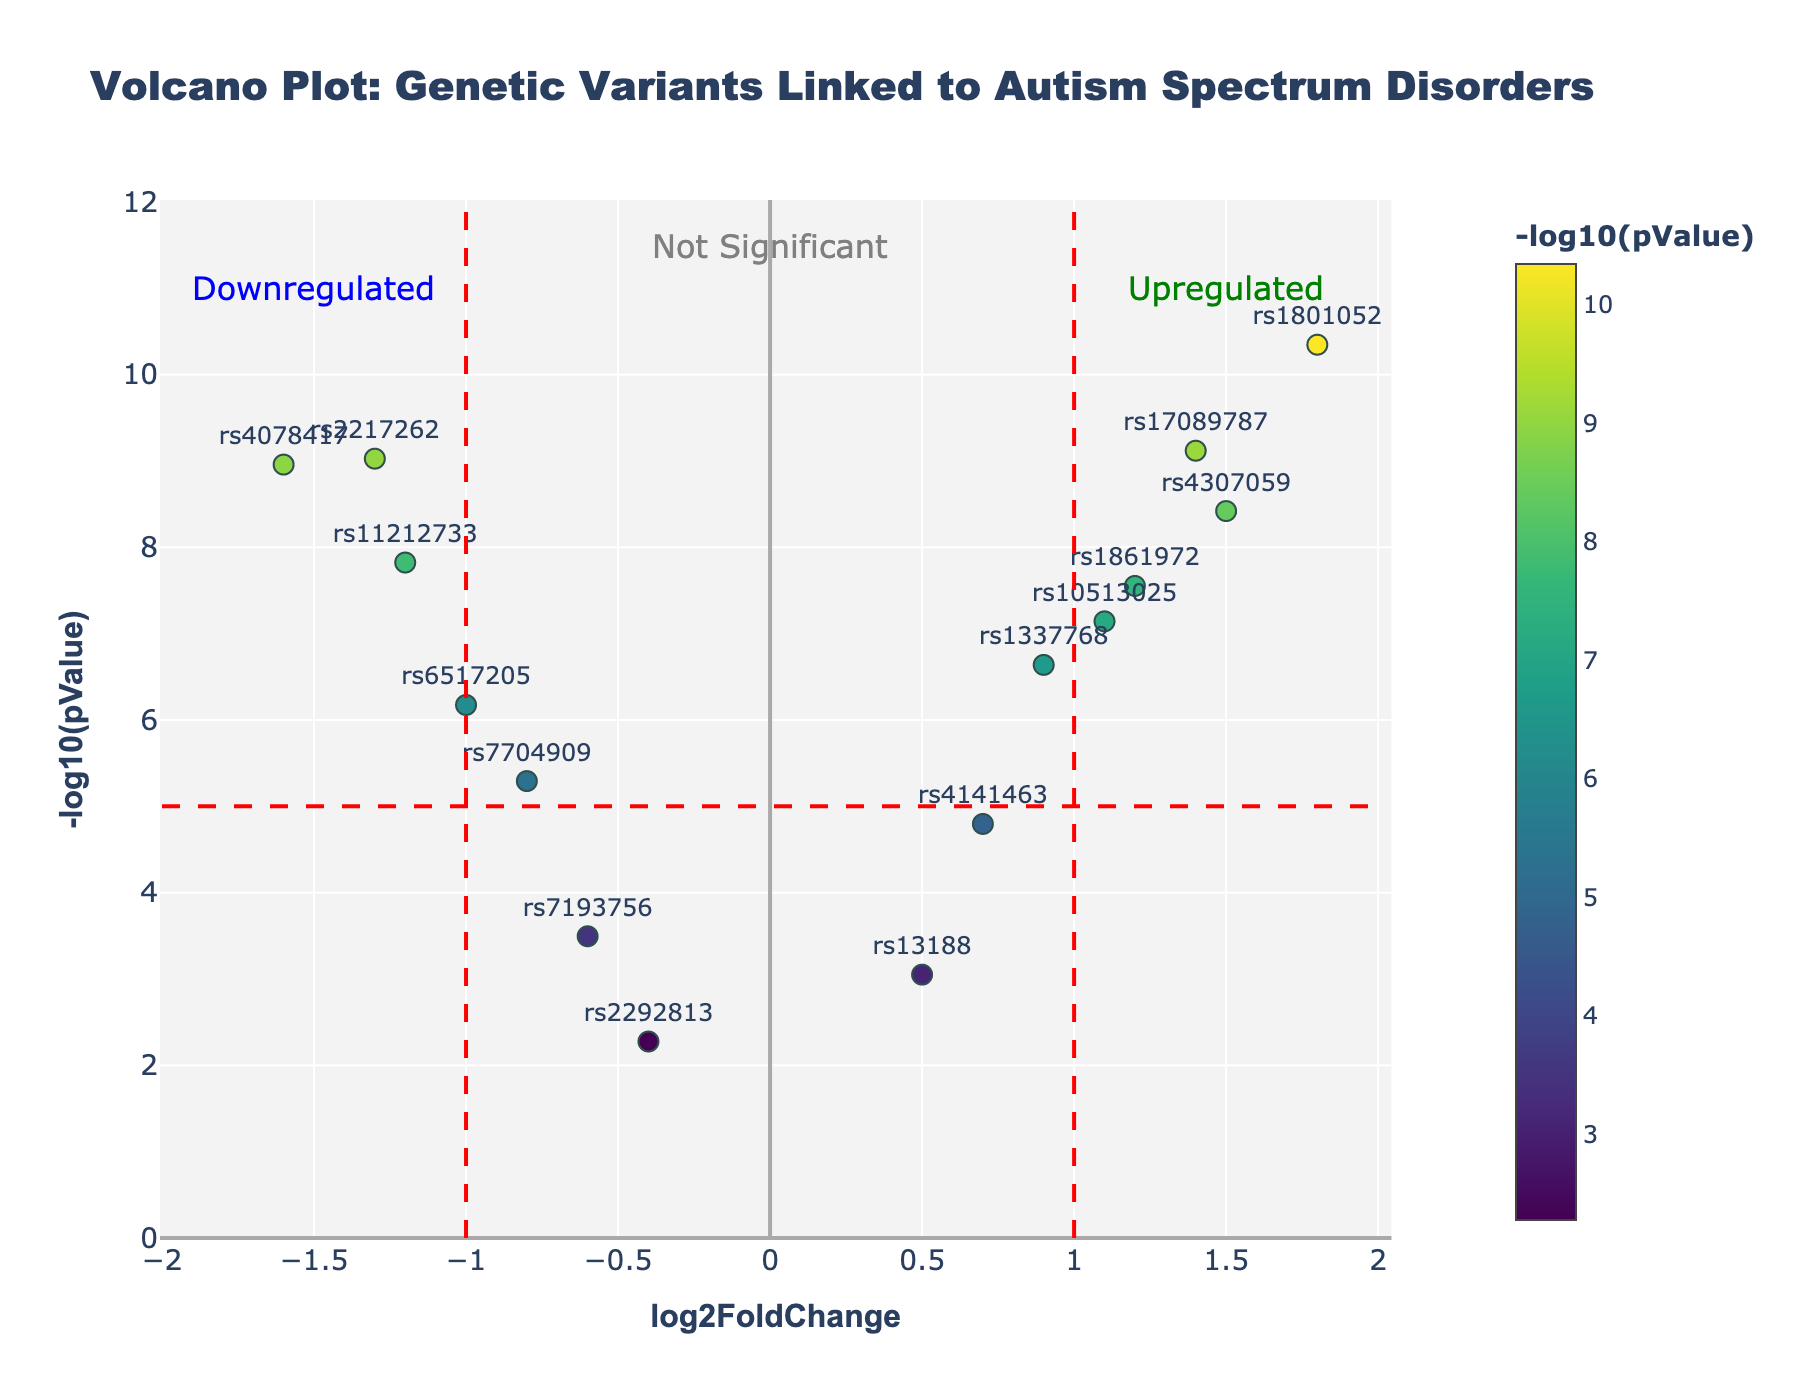What is the title of the plot? The title of the plot is displayed at the top center of the figure. It reads: "Volcano Plot: Genetic Variants Linked to Autism Spectrum Disorders".
Answer: "Volcano Plot: Genetic Variants Linked to Autism Spectrum Disorders" How many SNPs are in the dataset? To determine the number of SNPs, count the unique data points labeled with SNP names in the plot. There are 14 SNPs listed in the dataset.
Answer: 14 Which SNP has the highest -log10(pValue) and what is its log2FoldChange? The highest -log10(pValue) value corresponds to the highest point on the y-axis. SNP rs1801052 is the highest, and its log2FoldChange is 1.8.
Answer: rs1801052, 1.8 What do the dashed red vertical lines represent? The dashed red vertical lines are positioned at x = -1 and x = 1. They likely represent the thresholds for significant log2FoldChange, with values outside these lines indicating upregulation and downregulation.
Answer: Thresholds for significant log2FoldChange Between which log2FoldChange values do most of the non-significant SNPs lie? Most non-significant SNPs are below the horizontal red dashed line at y = 5 (indicating -log10(pValue) < 5). These points lie within the region approximately from log2FoldChange -1 to 1.
Answer: Between -1 and 1 How many SNPs are classified as significantly upregulated? Significantly upregulated SNPs are those to the right of the vertical dashed line at x = 1 and above the horizontal dashed line at y = 5. There are 5 such SNPs: rs1801052, rs4307059, rs10513025, rs1861972, and rs17089787.
Answer: 5 Which SNP is the most significantly downregulated in the data? The most significantly downregulated SNP is the one with the lowest log2FoldChange (most negative) among the significant SNPs (above y = 5). This is rs4078417 with a log2FoldChange of -1.6.
Answer: rs4078417 What does the color scale in the plot represent? The color scale, shown by the color bar with the title -log10(pValue), represents the -log10(pValue) values of the SNPs. Darker colors indicate higher -log10(pValue) values.
Answer: -log10(pValue) Based on the plot, can you mention the SNP with the smallest log2FoldChange? To find the SNP with the smallest log2FoldChange, look for the point furthest left on the x-axis. The SNP with the smallest log2FoldChange is rs4078417 with a log2FoldChange of -1.6.
Answer: rs4078417 